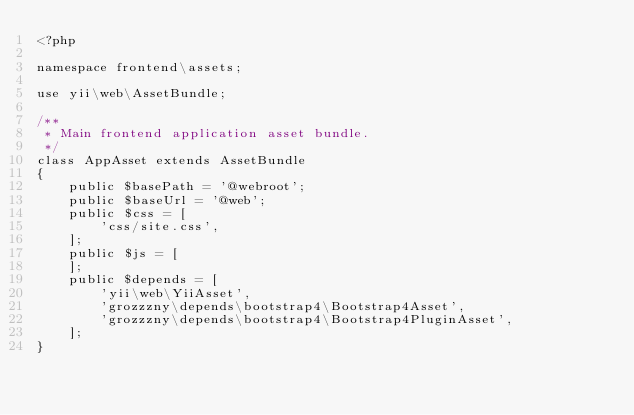<code> <loc_0><loc_0><loc_500><loc_500><_PHP_><?php

namespace frontend\assets;

use yii\web\AssetBundle;

/**
 * Main frontend application asset bundle.
 */
class AppAsset extends AssetBundle
{
    public $basePath = '@webroot';
    public $baseUrl = '@web';
    public $css = [
        'css/site.css',
    ];
    public $js = [
    ];
    public $depends = [
        'yii\web\YiiAsset',
        'grozzzny\depends\bootstrap4\Bootstrap4Asset',
        'grozzzny\depends\bootstrap4\Bootstrap4PluginAsset',
    ];
}
</code> 